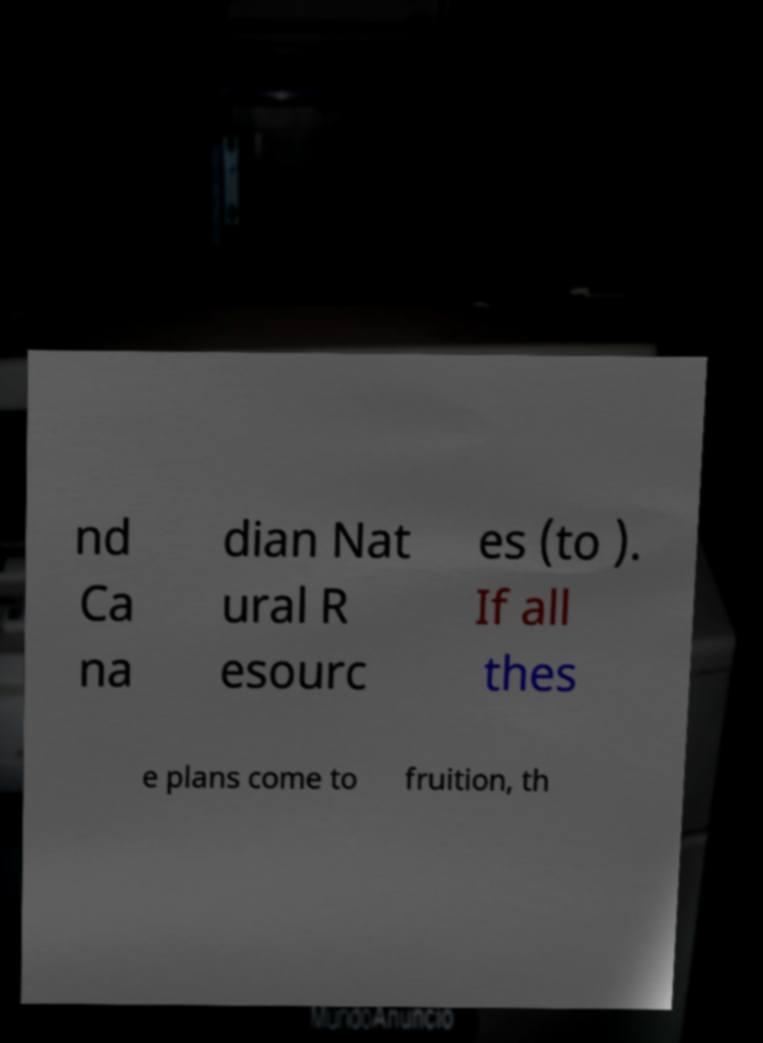I need the written content from this picture converted into text. Can you do that? nd Ca na dian Nat ural R esourc es (to ). If all thes e plans come to fruition, th 